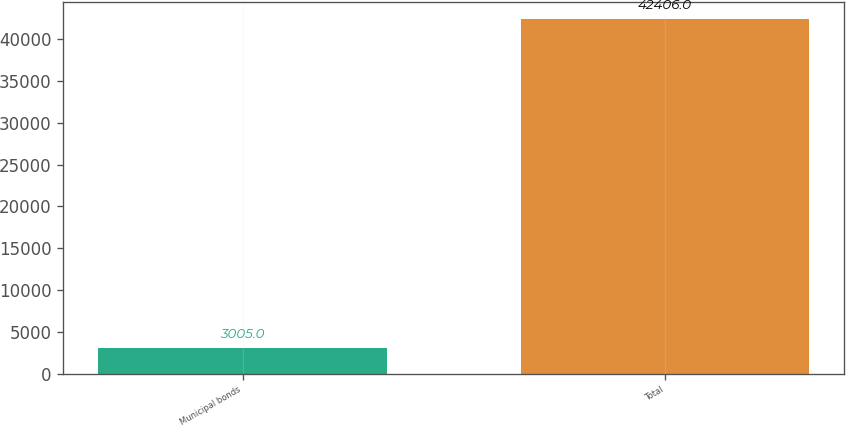<chart> <loc_0><loc_0><loc_500><loc_500><bar_chart><fcel>Municipal bonds<fcel>Total<nl><fcel>3005<fcel>42406<nl></chart> 